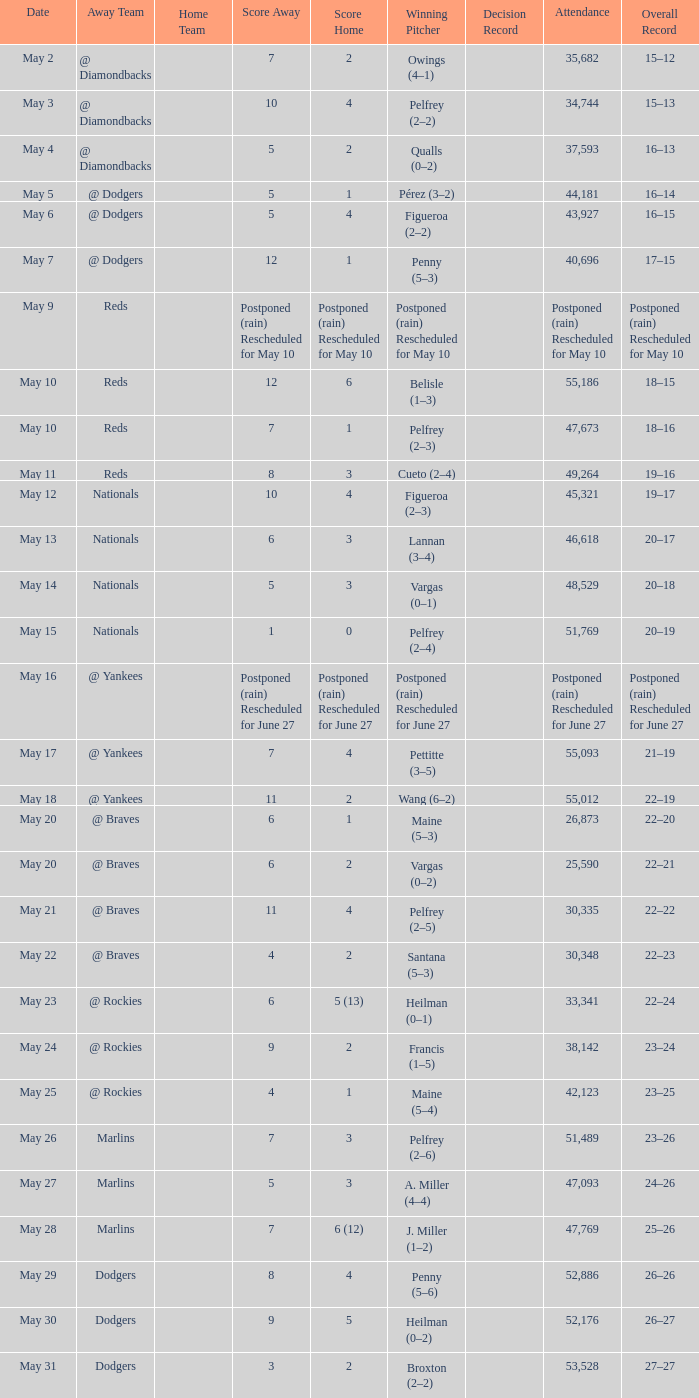Parse the full table. {'header': ['Date', 'Away Team', 'Home Team', 'Score Away', 'Score Home', 'Winning Pitcher', 'Decision Record', 'Attendance', 'Overall Record'], 'rows': [['May 2', '@ Diamondbacks', '', '7', '2', 'Owings (4–1)', '', '35,682', '15–12'], ['May 3', '@ Diamondbacks', '', '10', '4', 'Pelfrey (2–2)', '', '34,744', '15–13'], ['May 4', '@ Diamondbacks', '', '5', '2', 'Qualls (0–2)', '', '37,593', '16–13'], ['May 5', '@ Dodgers', '', '5', '1', 'Pérez (3–2)', '', '44,181', '16–14'], ['May 6', '@ Dodgers', '', '5', '4', 'Figueroa (2–2)', '', '43,927', '16–15'], ['May 7', '@ Dodgers', '', '12', '1', 'Penny (5–3)', '', '40,696', '17–15'], ['May 9', 'Reds', '', 'Postponed (rain) Rescheduled for May 10', 'Postponed (rain) Rescheduled for May 10', 'Postponed (rain) Rescheduled for May 10', '', 'Postponed (rain) Rescheduled for May 10', 'Postponed (rain) Rescheduled for May 10'], ['May 10', 'Reds', '', '12', '6', 'Belisle (1–3)', '', '55,186', '18–15'], ['May 10', 'Reds', '', '7', '1', 'Pelfrey (2–3)', '', '47,673', '18–16'], ['May 11', 'Reds', '', '8', '3', 'Cueto (2–4)', '', '49,264', '19–16'], ['May 12', 'Nationals', '', '10', '4', 'Figueroa (2–3)', '', '45,321', '19–17'], ['May 13', 'Nationals', '', '6', '3', 'Lannan (3–4)', '', '46,618', '20–17'], ['May 14', 'Nationals', '', '5', '3', 'Vargas (0–1)', '', '48,529', '20–18'], ['May 15', 'Nationals', '', '1', '0', 'Pelfrey (2–4)', '', '51,769', '20–19'], ['May 16', '@ Yankees', '', 'Postponed (rain) Rescheduled for June 27', 'Postponed (rain) Rescheduled for June 27', 'Postponed (rain) Rescheduled for June 27', '', 'Postponed (rain) Rescheduled for June 27', 'Postponed (rain) Rescheduled for June 27'], ['May 17', '@ Yankees', '', '7', '4', 'Pettitte (3–5)', '', '55,093', '21–19'], ['May 18', '@ Yankees', '', '11', '2', 'Wang (6–2)', '', '55,012', '22–19'], ['May 20', '@ Braves', '', '6', '1', 'Maine (5–3)', '', '26,873', '22–20'], ['May 20', '@ Braves', '', '6', '2', 'Vargas (0–2)', '', '25,590', '22–21'], ['May 21', '@ Braves', '', '11', '4', 'Pelfrey (2–5)', '', '30,335', '22–22'], ['May 22', '@ Braves', '', '4', '2', 'Santana (5–3)', '', '30,348', '22–23'], ['May 23', '@ Rockies', '', '6', '5 (13)', 'Heilman (0–1)', '', '33,341', '22–24'], ['May 24', '@ Rockies', '', '9', '2', 'Francis (1–5)', '', '38,142', '23–24'], ['May 25', '@ Rockies', '', '4', '1', 'Maine (5–4)', '', '42,123', '23–25'], ['May 26', 'Marlins', '', '7', '3', 'Pelfrey (2–6)', '', '51,489', '23–26'], ['May 27', 'Marlins', '', '5', '3', 'A. Miller (4–4)', '', '47,093', '24–26'], ['May 28', 'Marlins', '', '7', '6 (12)', 'J. Miller (1–2)', '', '47,769', '25–26'], ['May 29', 'Dodgers', '', '8', '4', 'Penny (5–6)', '', '52,886', '26–26'], ['May 30', 'Dodgers', '', '9', '5', 'Heilman (0–2)', '', '52,176', '26–27'], ['May 31', 'Dodgers', '', '3', '2', 'Broxton (2–2)', '', '53,528', '27–27']]} Attendance of 30,335 had what record? 22–22. 